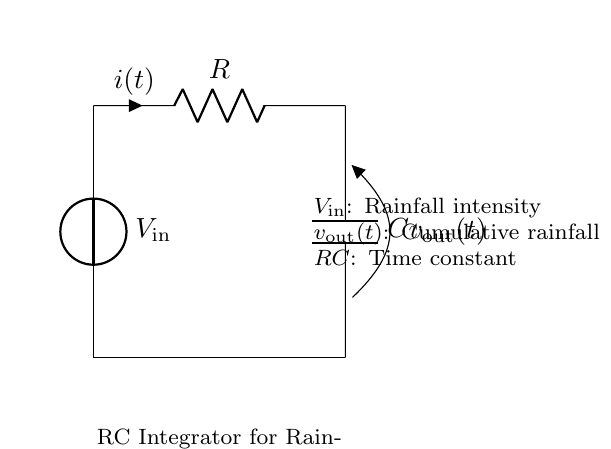What is the input voltage of the circuit? The input voltage is labeled as V_in in the circuit diagram. It is the voltage source providing the input signal, which represents the rainfall intensity.
Answer: V_in What component is used to store energy in this circuit? The component used to store energy in this RC integrator circuit is the capacitor, labeled as C. Capacitors store energy in the electric field when voltage is applied across them.
Answer: C What does v_out(t) represent in this circuit? The output voltage, denoted as v_out(t), represents the cumulative rainfall over time. It is the voltage across the capacitor, which integrates the input voltage over time.
Answer: Cumulative rainfall What is the function of the resistor in this circuit? The resistor, labeled as R, limits the current flow in the circuit. In this RC integrator, it also affects the time constant (RC), determining how quickly the capacitor charges in response to the input voltage.
Answer: Limits current How does increasing the resistance value affect the time constant? The time constant is calculated as the product of resistance (R) and capacitance (C). If resistance increases while capacitance remains constant, the time constant also increases, resulting in slower charging of the capacitor and a longer response time to changes in input voltage.
Answer: Increases time constant What happens to v_out(t) when V_in is suddenly turned off? When V_in is suddenly turned off, the output voltage v_out(t) will gradually decrease as the capacitor discharges. The rate of discharge is affected by the resistance in the circuit.
Answer: Gradually decreases 